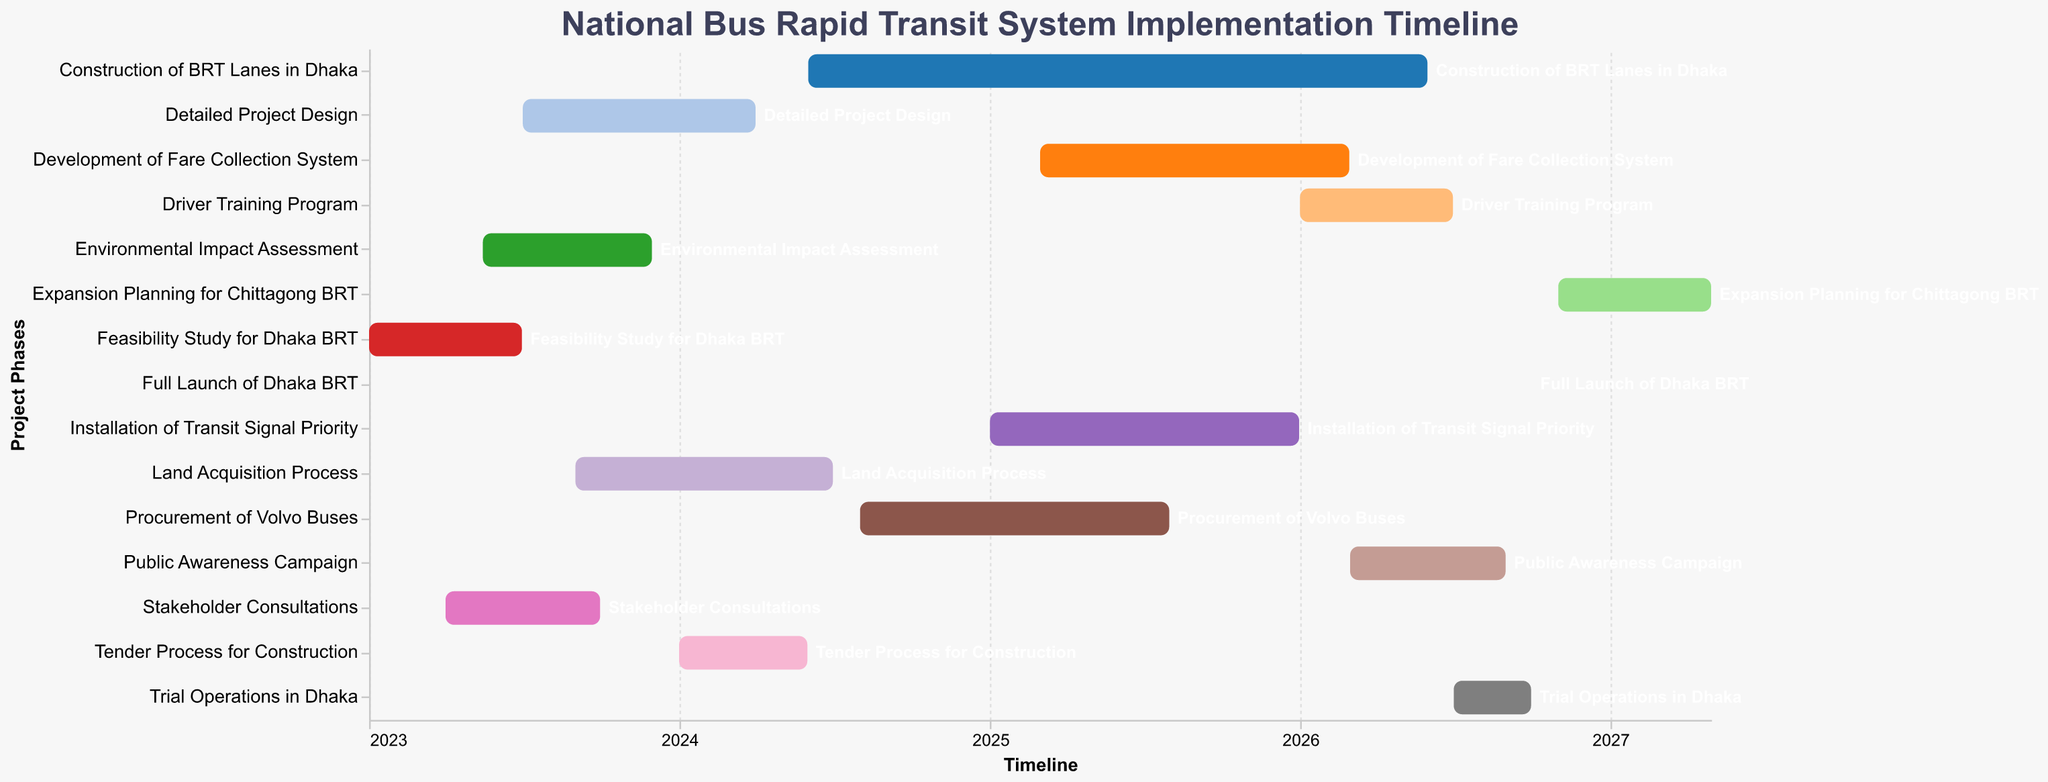What's the title of the figure? The title is typically found at the top of the chart and provides a summary of what the chart represents.
Answer: National Bus Rapid Transit System Implementation Timeline What task is represented by the first bar on the chart? The first bar usually represents the earliest task in temporal charts. Here, the earliest task starts on 2023-01-01.
Answer: Feasibility Study for Dhaka BRT How long does the "Stakeholder Consultations" phase last? By finding the "Stakeholder Consultations" task and looking at its start and end dates, we can compute the duration. Start date: 2023-04-01, End date: 2023-09-30.
Answer: 6 months Which task has the shortest duration? By comparing the duration (end date minus start date) of all tasks, we see that the "Full Launch of Dhaka BRT" task, being a single day (2026-10-01).
Answer: Full Launch of Dhaka BRT What is the total duration of the "Construction of BRT Lanes in Dhaka" phase? We look for the "Construction of BRT Lanes in Dhaka" task and find its start and end dates: 2024-06-01 to 2026-05-31, then compute the difference.
Answer: 2 years Which tasks overlap with the "Environmental Impact Assessment" phase? We identify periods overlapping with 2023-05-15 to 2023-11-30. "Stakeholder Consultations" and "Detailed Project Design" overlap with these dates.
Answer: Stakeholder Consultations, Detailed Project Design How many tasks start in 2024? By counting tasks whose start date falls within the year 2024, we identify four tasks: "Detailed Project Design", "Tender Process for Construction", "Construction of BRT Lanes in Dhaka", and "Procurement of Volvo Buses".
Answer: 4 tasks What tasks follow immediately after the "Trial Operations in Dhaka"? We look at the chart to see the task starting immediately after 2026-09-30, which is "Full Launch of Dhaka BRT".
Answer: Full Launch of Dhaka BRT Which task takes place entirely in the year 2025? By identifying tasks with both start and end dates within 2025, we see "Installation of Transit Signal Priority".
Answer: Installation of Transit Signal Priority 